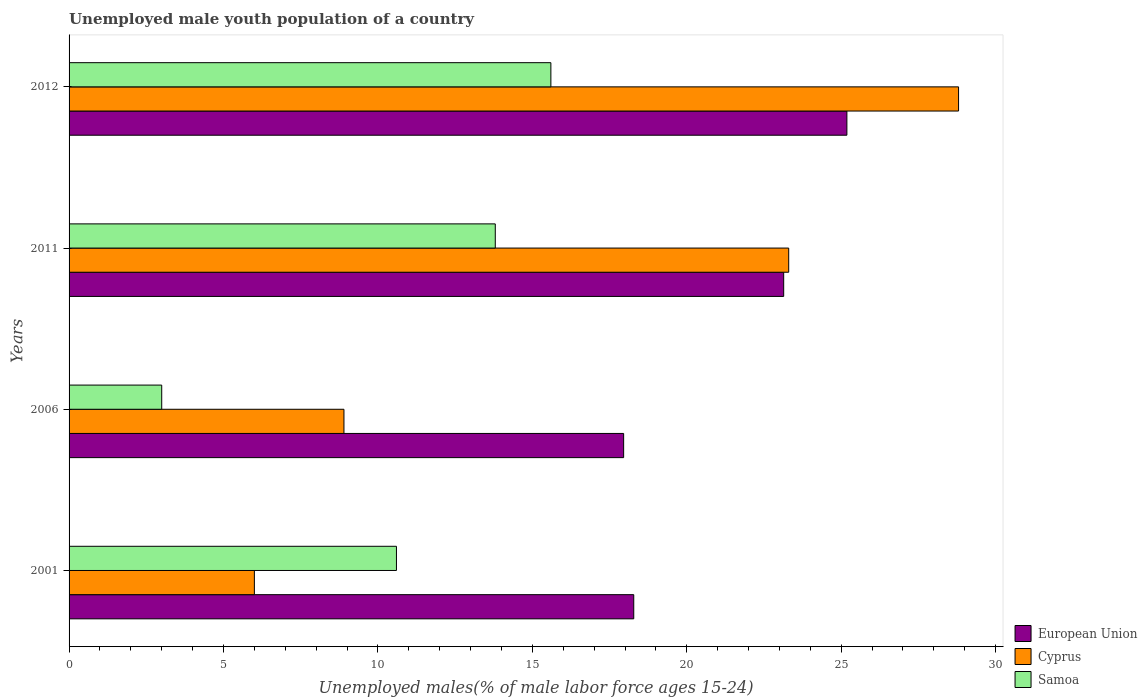How many different coloured bars are there?
Keep it short and to the point. 3. Are the number of bars per tick equal to the number of legend labels?
Offer a terse response. Yes. Are the number of bars on each tick of the Y-axis equal?
Your answer should be compact. Yes. How many bars are there on the 2nd tick from the bottom?
Make the answer very short. 3. In how many cases, is the number of bars for a given year not equal to the number of legend labels?
Make the answer very short. 0. What is the percentage of unemployed male youth population in European Union in 2011?
Provide a succinct answer. 23.14. Across all years, what is the maximum percentage of unemployed male youth population in Cyprus?
Keep it short and to the point. 28.8. Across all years, what is the minimum percentage of unemployed male youth population in European Union?
Provide a short and direct response. 17.96. In which year was the percentage of unemployed male youth population in European Union maximum?
Ensure brevity in your answer.  2012. What is the total percentage of unemployed male youth population in Cyprus in the graph?
Your response must be concise. 67. What is the difference between the percentage of unemployed male youth population in Samoa in 2011 and that in 2012?
Provide a short and direct response. -1.8. What is the difference between the percentage of unemployed male youth population in Cyprus in 2011 and the percentage of unemployed male youth population in European Union in 2012?
Offer a very short reply. -1.88. What is the average percentage of unemployed male youth population in European Union per year?
Offer a very short reply. 21.14. In the year 2001, what is the difference between the percentage of unemployed male youth population in Samoa and percentage of unemployed male youth population in Cyprus?
Your response must be concise. 4.6. What is the ratio of the percentage of unemployed male youth population in European Union in 2011 to that in 2012?
Keep it short and to the point. 0.92. Is the percentage of unemployed male youth population in Samoa in 2006 less than that in 2011?
Keep it short and to the point. Yes. What is the difference between the highest and the second highest percentage of unemployed male youth population in Samoa?
Your answer should be compact. 1.8. What is the difference between the highest and the lowest percentage of unemployed male youth population in European Union?
Your answer should be compact. 7.23. What does the 1st bar from the top in 2012 represents?
Your answer should be compact. Samoa. What does the 3rd bar from the bottom in 2001 represents?
Offer a very short reply. Samoa. Is it the case that in every year, the sum of the percentage of unemployed male youth population in European Union and percentage of unemployed male youth population in Samoa is greater than the percentage of unemployed male youth population in Cyprus?
Keep it short and to the point. Yes. Does the graph contain any zero values?
Offer a terse response. No. Does the graph contain grids?
Ensure brevity in your answer.  No. Where does the legend appear in the graph?
Make the answer very short. Bottom right. What is the title of the graph?
Provide a succinct answer. Unemployed male youth population of a country. What is the label or title of the X-axis?
Give a very brief answer. Unemployed males(% of male labor force ages 15-24). What is the label or title of the Y-axis?
Provide a short and direct response. Years. What is the Unemployed males(% of male labor force ages 15-24) of European Union in 2001?
Provide a succinct answer. 18.28. What is the Unemployed males(% of male labor force ages 15-24) of Samoa in 2001?
Ensure brevity in your answer.  10.6. What is the Unemployed males(% of male labor force ages 15-24) of European Union in 2006?
Offer a terse response. 17.96. What is the Unemployed males(% of male labor force ages 15-24) in Cyprus in 2006?
Offer a very short reply. 8.9. What is the Unemployed males(% of male labor force ages 15-24) in European Union in 2011?
Provide a short and direct response. 23.14. What is the Unemployed males(% of male labor force ages 15-24) of Cyprus in 2011?
Keep it short and to the point. 23.3. What is the Unemployed males(% of male labor force ages 15-24) in Samoa in 2011?
Your answer should be compact. 13.8. What is the Unemployed males(% of male labor force ages 15-24) in European Union in 2012?
Give a very brief answer. 25.18. What is the Unemployed males(% of male labor force ages 15-24) in Cyprus in 2012?
Your answer should be very brief. 28.8. What is the Unemployed males(% of male labor force ages 15-24) of Samoa in 2012?
Provide a short and direct response. 15.6. Across all years, what is the maximum Unemployed males(% of male labor force ages 15-24) in European Union?
Make the answer very short. 25.18. Across all years, what is the maximum Unemployed males(% of male labor force ages 15-24) of Cyprus?
Offer a very short reply. 28.8. Across all years, what is the maximum Unemployed males(% of male labor force ages 15-24) of Samoa?
Ensure brevity in your answer.  15.6. Across all years, what is the minimum Unemployed males(% of male labor force ages 15-24) of European Union?
Your answer should be very brief. 17.96. Across all years, what is the minimum Unemployed males(% of male labor force ages 15-24) of Cyprus?
Your response must be concise. 6. Across all years, what is the minimum Unemployed males(% of male labor force ages 15-24) in Samoa?
Keep it short and to the point. 3. What is the total Unemployed males(% of male labor force ages 15-24) of European Union in the graph?
Ensure brevity in your answer.  84.56. What is the difference between the Unemployed males(% of male labor force ages 15-24) of European Union in 2001 and that in 2006?
Keep it short and to the point. 0.33. What is the difference between the Unemployed males(% of male labor force ages 15-24) in European Union in 2001 and that in 2011?
Give a very brief answer. -4.85. What is the difference between the Unemployed males(% of male labor force ages 15-24) of Cyprus in 2001 and that in 2011?
Your answer should be very brief. -17.3. What is the difference between the Unemployed males(% of male labor force ages 15-24) in Samoa in 2001 and that in 2011?
Keep it short and to the point. -3.2. What is the difference between the Unemployed males(% of male labor force ages 15-24) in European Union in 2001 and that in 2012?
Your answer should be very brief. -6.9. What is the difference between the Unemployed males(% of male labor force ages 15-24) of Cyprus in 2001 and that in 2012?
Keep it short and to the point. -22.8. What is the difference between the Unemployed males(% of male labor force ages 15-24) of European Union in 2006 and that in 2011?
Give a very brief answer. -5.18. What is the difference between the Unemployed males(% of male labor force ages 15-24) of Cyprus in 2006 and that in 2011?
Your answer should be very brief. -14.4. What is the difference between the Unemployed males(% of male labor force ages 15-24) in European Union in 2006 and that in 2012?
Your response must be concise. -7.23. What is the difference between the Unemployed males(% of male labor force ages 15-24) in Cyprus in 2006 and that in 2012?
Your response must be concise. -19.9. What is the difference between the Unemployed males(% of male labor force ages 15-24) of European Union in 2011 and that in 2012?
Provide a short and direct response. -2.05. What is the difference between the Unemployed males(% of male labor force ages 15-24) of Samoa in 2011 and that in 2012?
Your answer should be compact. -1.8. What is the difference between the Unemployed males(% of male labor force ages 15-24) of European Union in 2001 and the Unemployed males(% of male labor force ages 15-24) of Cyprus in 2006?
Offer a very short reply. 9.38. What is the difference between the Unemployed males(% of male labor force ages 15-24) of European Union in 2001 and the Unemployed males(% of male labor force ages 15-24) of Samoa in 2006?
Give a very brief answer. 15.28. What is the difference between the Unemployed males(% of male labor force ages 15-24) in Cyprus in 2001 and the Unemployed males(% of male labor force ages 15-24) in Samoa in 2006?
Give a very brief answer. 3. What is the difference between the Unemployed males(% of male labor force ages 15-24) in European Union in 2001 and the Unemployed males(% of male labor force ages 15-24) in Cyprus in 2011?
Your answer should be compact. -5.02. What is the difference between the Unemployed males(% of male labor force ages 15-24) in European Union in 2001 and the Unemployed males(% of male labor force ages 15-24) in Samoa in 2011?
Offer a terse response. 4.48. What is the difference between the Unemployed males(% of male labor force ages 15-24) of European Union in 2001 and the Unemployed males(% of male labor force ages 15-24) of Cyprus in 2012?
Provide a short and direct response. -10.52. What is the difference between the Unemployed males(% of male labor force ages 15-24) of European Union in 2001 and the Unemployed males(% of male labor force ages 15-24) of Samoa in 2012?
Provide a succinct answer. 2.68. What is the difference between the Unemployed males(% of male labor force ages 15-24) of Cyprus in 2001 and the Unemployed males(% of male labor force ages 15-24) of Samoa in 2012?
Provide a short and direct response. -9.6. What is the difference between the Unemployed males(% of male labor force ages 15-24) in European Union in 2006 and the Unemployed males(% of male labor force ages 15-24) in Cyprus in 2011?
Your response must be concise. -5.34. What is the difference between the Unemployed males(% of male labor force ages 15-24) in European Union in 2006 and the Unemployed males(% of male labor force ages 15-24) in Samoa in 2011?
Your answer should be very brief. 4.16. What is the difference between the Unemployed males(% of male labor force ages 15-24) of European Union in 2006 and the Unemployed males(% of male labor force ages 15-24) of Cyprus in 2012?
Keep it short and to the point. -10.84. What is the difference between the Unemployed males(% of male labor force ages 15-24) in European Union in 2006 and the Unemployed males(% of male labor force ages 15-24) in Samoa in 2012?
Give a very brief answer. 2.36. What is the difference between the Unemployed males(% of male labor force ages 15-24) in European Union in 2011 and the Unemployed males(% of male labor force ages 15-24) in Cyprus in 2012?
Your response must be concise. -5.66. What is the difference between the Unemployed males(% of male labor force ages 15-24) of European Union in 2011 and the Unemployed males(% of male labor force ages 15-24) of Samoa in 2012?
Your answer should be compact. 7.54. What is the average Unemployed males(% of male labor force ages 15-24) in European Union per year?
Offer a very short reply. 21.14. What is the average Unemployed males(% of male labor force ages 15-24) in Cyprus per year?
Keep it short and to the point. 16.75. What is the average Unemployed males(% of male labor force ages 15-24) in Samoa per year?
Your answer should be very brief. 10.75. In the year 2001, what is the difference between the Unemployed males(% of male labor force ages 15-24) of European Union and Unemployed males(% of male labor force ages 15-24) of Cyprus?
Keep it short and to the point. 12.28. In the year 2001, what is the difference between the Unemployed males(% of male labor force ages 15-24) of European Union and Unemployed males(% of male labor force ages 15-24) of Samoa?
Provide a succinct answer. 7.68. In the year 2001, what is the difference between the Unemployed males(% of male labor force ages 15-24) of Cyprus and Unemployed males(% of male labor force ages 15-24) of Samoa?
Make the answer very short. -4.6. In the year 2006, what is the difference between the Unemployed males(% of male labor force ages 15-24) of European Union and Unemployed males(% of male labor force ages 15-24) of Cyprus?
Ensure brevity in your answer.  9.06. In the year 2006, what is the difference between the Unemployed males(% of male labor force ages 15-24) of European Union and Unemployed males(% of male labor force ages 15-24) of Samoa?
Keep it short and to the point. 14.96. In the year 2011, what is the difference between the Unemployed males(% of male labor force ages 15-24) of European Union and Unemployed males(% of male labor force ages 15-24) of Cyprus?
Your response must be concise. -0.16. In the year 2011, what is the difference between the Unemployed males(% of male labor force ages 15-24) in European Union and Unemployed males(% of male labor force ages 15-24) in Samoa?
Provide a short and direct response. 9.34. In the year 2012, what is the difference between the Unemployed males(% of male labor force ages 15-24) in European Union and Unemployed males(% of male labor force ages 15-24) in Cyprus?
Ensure brevity in your answer.  -3.62. In the year 2012, what is the difference between the Unemployed males(% of male labor force ages 15-24) of European Union and Unemployed males(% of male labor force ages 15-24) of Samoa?
Keep it short and to the point. 9.58. What is the ratio of the Unemployed males(% of male labor force ages 15-24) of European Union in 2001 to that in 2006?
Ensure brevity in your answer.  1.02. What is the ratio of the Unemployed males(% of male labor force ages 15-24) in Cyprus in 2001 to that in 2006?
Provide a short and direct response. 0.67. What is the ratio of the Unemployed males(% of male labor force ages 15-24) in Samoa in 2001 to that in 2006?
Give a very brief answer. 3.53. What is the ratio of the Unemployed males(% of male labor force ages 15-24) in European Union in 2001 to that in 2011?
Your answer should be compact. 0.79. What is the ratio of the Unemployed males(% of male labor force ages 15-24) in Cyprus in 2001 to that in 2011?
Your response must be concise. 0.26. What is the ratio of the Unemployed males(% of male labor force ages 15-24) of Samoa in 2001 to that in 2011?
Your answer should be very brief. 0.77. What is the ratio of the Unemployed males(% of male labor force ages 15-24) in European Union in 2001 to that in 2012?
Offer a terse response. 0.73. What is the ratio of the Unemployed males(% of male labor force ages 15-24) of Cyprus in 2001 to that in 2012?
Offer a very short reply. 0.21. What is the ratio of the Unemployed males(% of male labor force ages 15-24) of Samoa in 2001 to that in 2012?
Ensure brevity in your answer.  0.68. What is the ratio of the Unemployed males(% of male labor force ages 15-24) of European Union in 2006 to that in 2011?
Your answer should be very brief. 0.78. What is the ratio of the Unemployed males(% of male labor force ages 15-24) of Cyprus in 2006 to that in 2011?
Make the answer very short. 0.38. What is the ratio of the Unemployed males(% of male labor force ages 15-24) in Samoa in 2006 to that in 2011?
Keep it short and to the point. 0.22. What is the ratio of the Unemployed males(% of male labor force ages 15-24) in European Union in 2006 to that in 2012?
Your answer should be compact. 0.71. What is the ratio of the Unemployed males(% of male labor force ages 15-24) of Cyprus in 2006 to that in 2012?
Provide a succinct answer. 0.31. What is the ratio of the Unemployed males(% of male labor force ages 15-24) in Samoa in 2006 to that in 2012?
Offer a very short reply. 0.19. What is the ratio of the Unemployed males(% of male labor force ages 15-24) in European Union in 2011 to that in 2012?
Your answer should be compact. 0.92. What is the ratio of the Unemployed males(% of male labor force ages 15-24) of Cyprus in 2011 to that in 2012?
Offer a terse response. 0.81. What is the ratio of the Unemployed males(% of male labor force ages 15-24) of Samoa in 2011 to that in 2012?
Offer a very short reply. 0.88. What is the difference between the highest and the second highest Unemployed males(% of male labor force ages 15-24) of European Union?
Keep it short and to the point. 2.05. What is the difference between the highest and the lowest Unemployed males(% of male labor force ages 15-24) in European Union?
Provide a succinct answer. 7.23. What is the difference between the highest and the lowest Unemployed males(% of male labor force ages 15-24) of Cyprus?
Provide a short and direct response. 22.8. What is the difference between the highest and the lowest Unemployed males(% of male labor force ages 15-24) in Samoa?
Give a very brief answer. 12.6. 